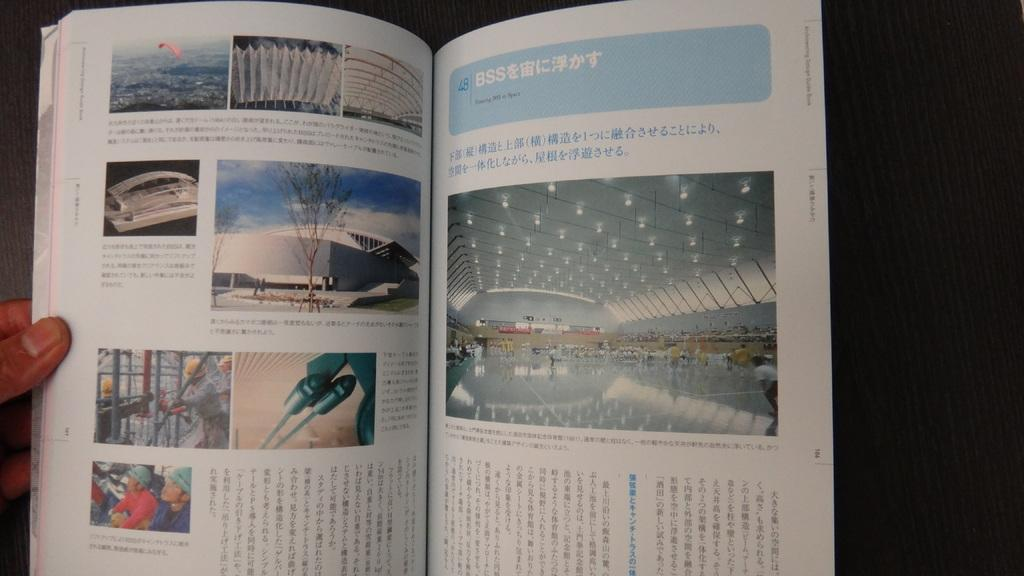<image>
Describe the image concisely. A book that is written in an oriental language. 